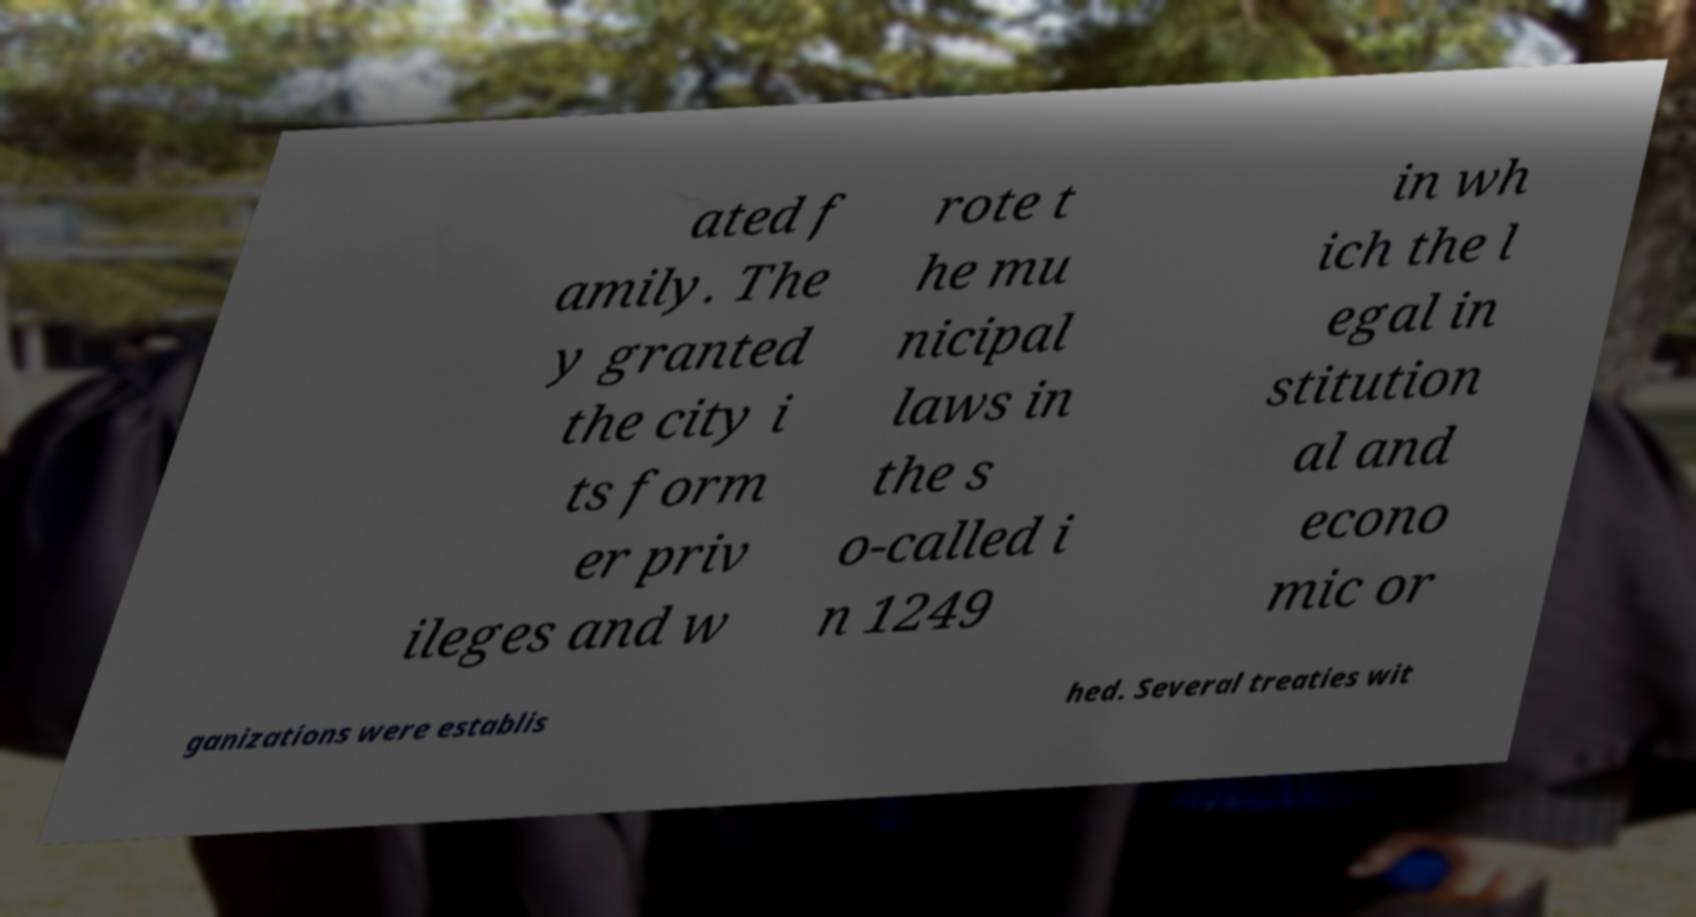I need the written content from this picture converted into text. Can you do that? ated f amily. The y granted the city i ts form er priv ileges and w rote t he mu nicipal laws in the s o-called i n 1249 in wh ich the l egal in stitution al and econo mic or ganizations were establis hed. Several treaties wit 